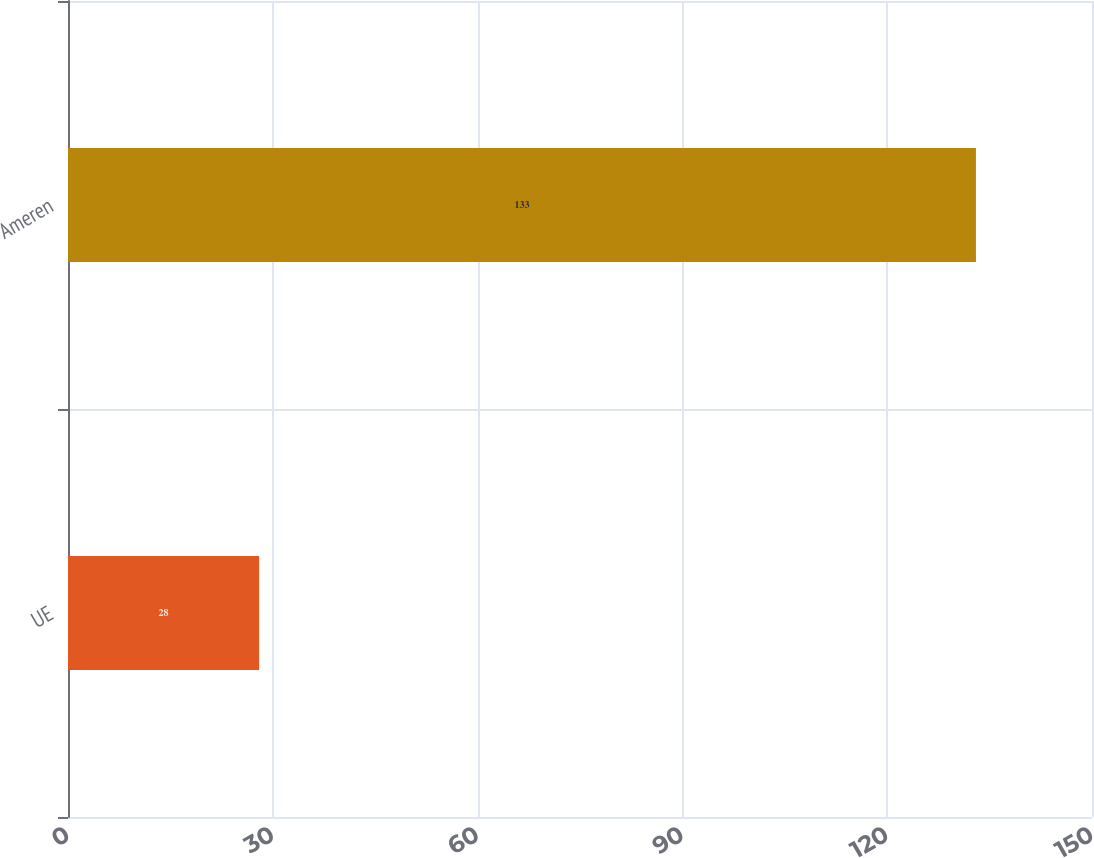Convert chart to OTSL. <chart><loc_0><loc_0><loc_500><loc_500><bar_chart><fcel>UE<fcel>Ameren<nl><fcel>28<fcel>133<nl></chart> 